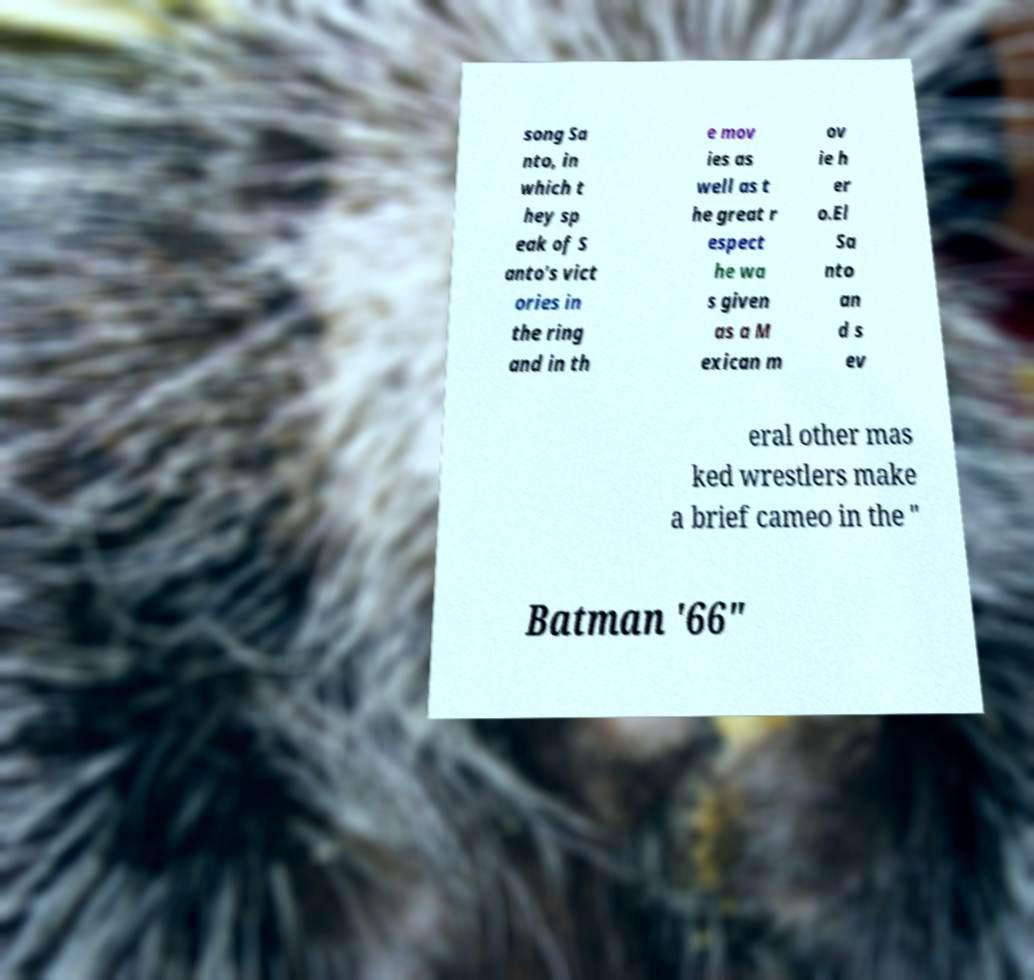What messages or text are displayed in this image? I need them in a readable, typed format. song Sa nto, in which t hey sp eak of S anto's vict ories in the ring and in th e mov ies as well as t he great r espect he wa s given as a M exican m ov ie h er o.El Sa nto an d s ev eral other mas ked wrestlers make a brief cameo in the " Batman '66" 